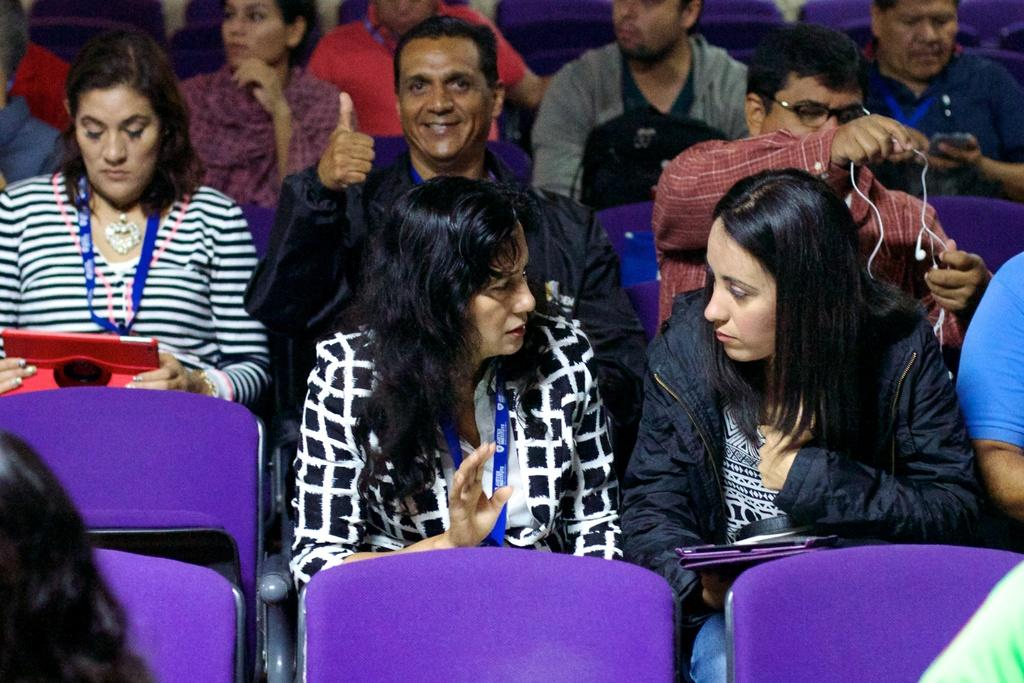What is the main subject of the image? The main subject of the image is a group of people. What are the people in the image doing? The people are seated on chairs. Can you describe the woman on the left side of the image? The woman on the left side of the image is holding a tablet. What type of sand can be seen in the image? There is no sand present in the image. What scientific discovery is the woman discussing with the group? The image does not provide any information about scientific discussions or discoveries. 